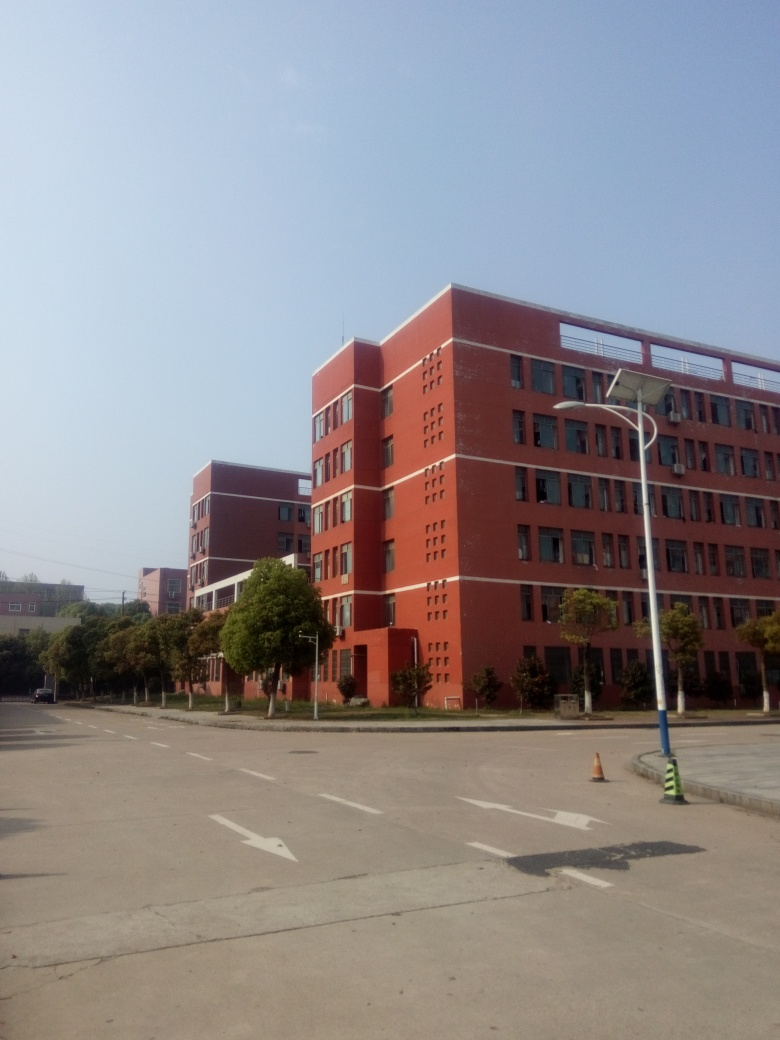Could you infer the possible use of the building based on its external features? Based on the external features such as the large number of windows, uniform design, and the building's substantial size, it may be used for institutional purposes such as education or administration. Often, such designs are indicative of places that require functional spaces for a large number of occupants, hinting at a school, university, or corporate building. 